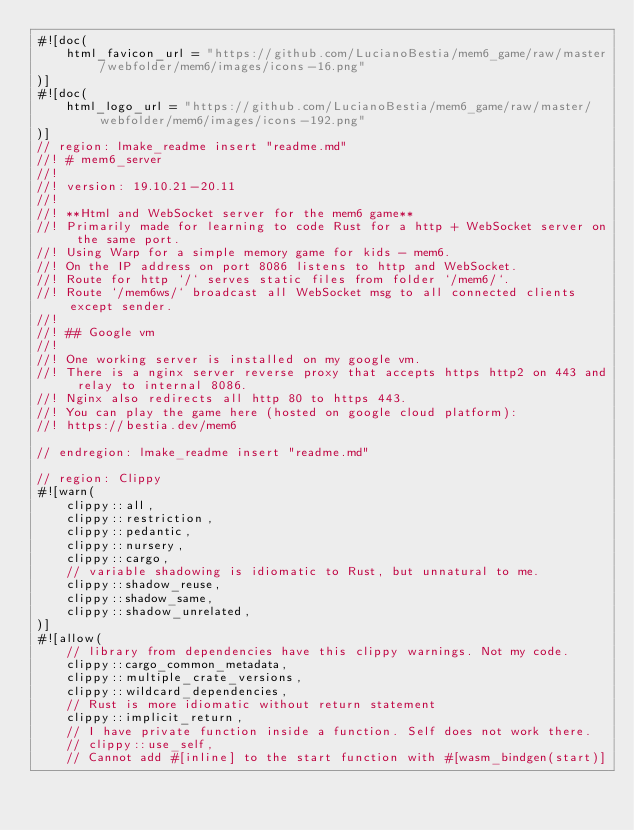<code> <loc_0><loc_0><loc_500><loc_500><_Rust_>#![doc(
    html_favicon_url = "https://github.com/LucianoBestia/mem6_game/raw/master/webfolder/mem6/images/icons-16.png"
)]
#![doc(
    html_logo_url = "https://github.com/LucianoBestia/mem6_game/raw/master/webfolder/mem6/images/icons-192.png"
)]
// region: lmake_readme insert "readme.md"
//! # mem6_server
//!
//! version: 19.10.21-20.11  
//!
//! **Html and WebSocket server for the mem6 game**  
//! Primarily made for learning to code Rust for a http + WebSocket server on the same port.  
//! Using Warp for a simple memory game for kids - mem6.  
//! On the IP address on port 8086 listens to http and WebSocket.  
//! Route for http `/` serves static files from folder `/mem6/`.  
//! Route `/mem6ws/` broadcast all WebSocket msg to all connected clients except sender.  
//!
//! ## Google vm
//!
//! One working server is installed on my google vm.  
//! There is a nginx server reverse proxy that accepts https http2 on 443 and relay to internal 8086.
//! Nginx also redirects all http 80 to https 443.  
//! You can play the game here (hosted on google cloud platform):  
//! https://bestia.dev/mem6  

// endregion: lmake_readme insert "readme.md"

// region: Clippy
#![warn(
    clippy::all,
    clippy::restriction,
    clippy::pedantic,
    clippy::nursery,
    clippy::cargo,
    // variable shadowing is idiomatic to Rust, but unnatural to me.
    clippy::shadow_reuse,
    clippy::shadow_same,
    clippy::shadow_unrelated,
)]
#![allow(
    // library from dependencies have this clippy warnings. Not my code.
    clippy::cargo_common_metadata,
    clippy::multiple_crate_versions,
    clippy::wildcard_dependencies,
    // Rust is more idiomatic without return statement
    clippy::implicit_return,
    // I have private function inside a function. Self does not work there.
    // clippy::use_self,
    // Cannot add #[inline] to the start function with #[wasm_bindgen(start)]</code> 